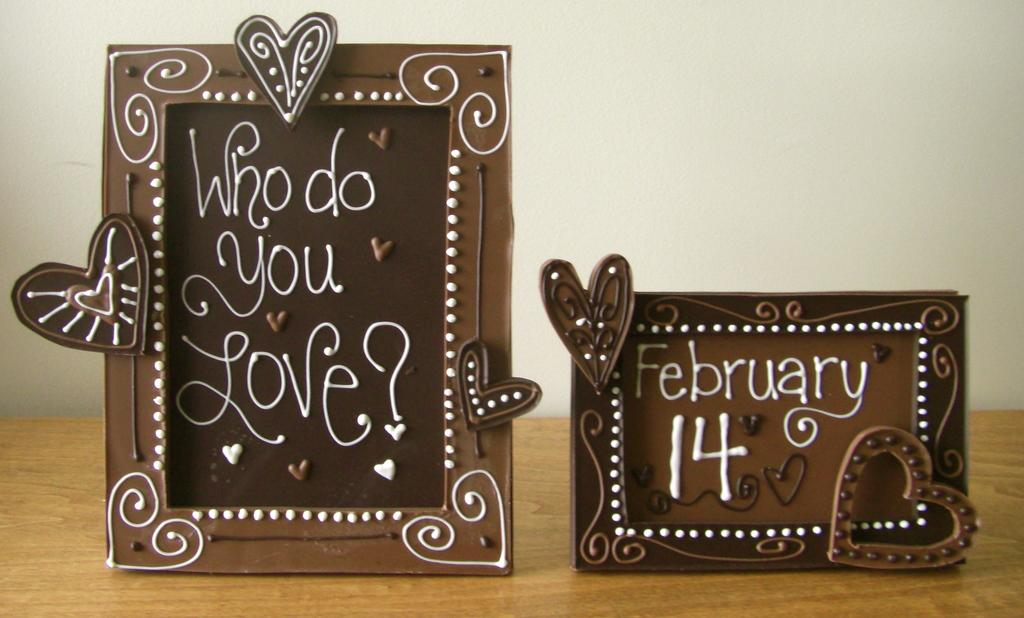What objects are present in the image that have a brown color? There are two brown frames in the image. What is written on the frames? Text is written on the frames. On what surface are the frames placed? The frames are placed on a wooden surface. What can be seen in the background of the image? There is a wall visible in the background of the image. Can you see a girl playing with a ball near the frames in the image? There is no girl or ball present in the image; it only features the two brown frames with text and a wooden surface. 